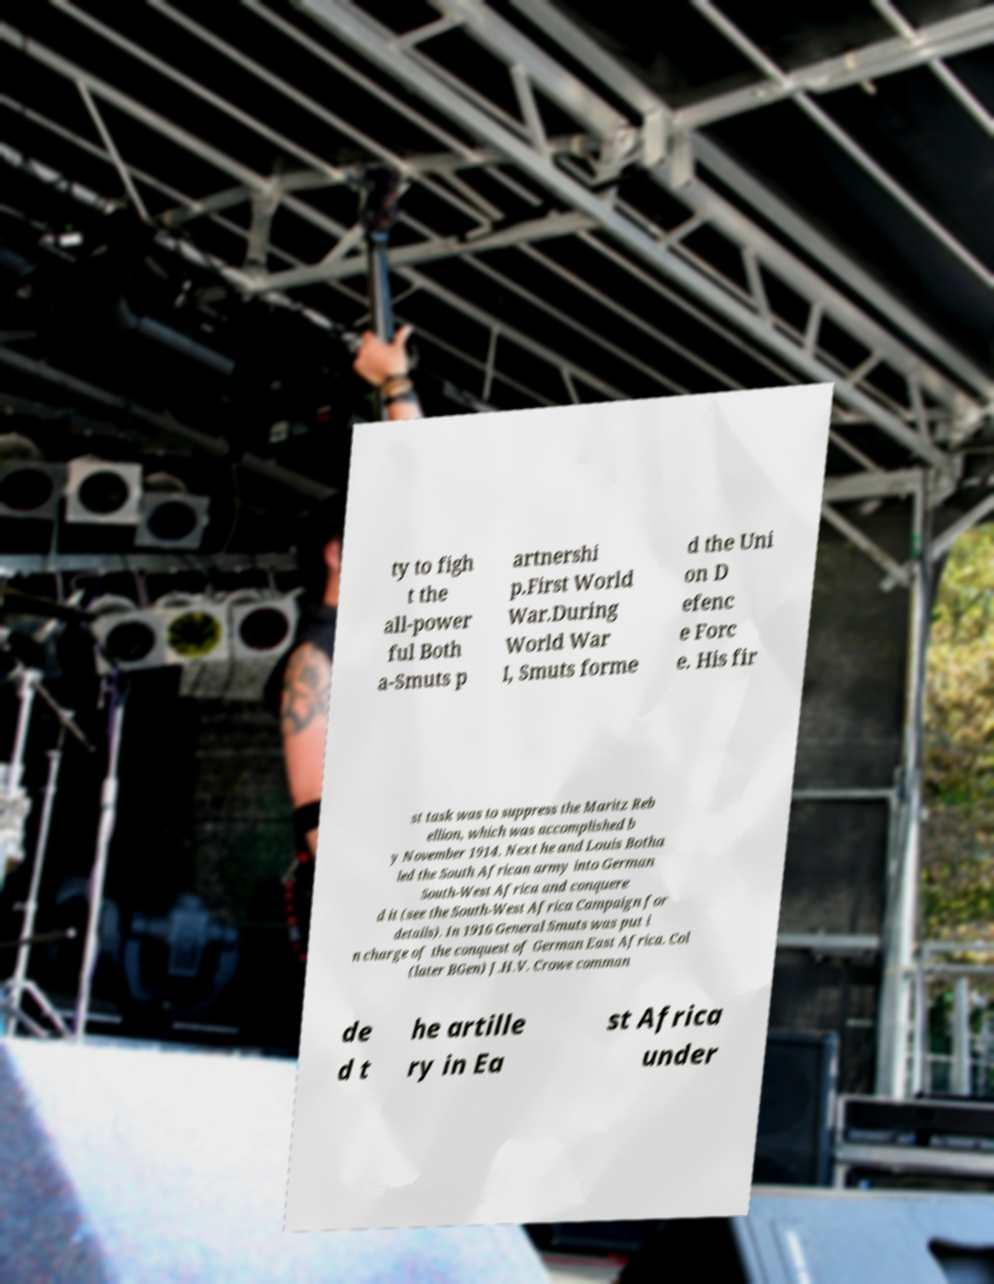I need the written content from this picture converted into text. Can you do that? ty to figh t the all-power ful Both a-Smuts p artnershi p.First World War.During World War I, Smuts forme d the Uni on D efenc e Forc e. His fir st task was to suppress the Maritz Reb ellion, which was accomplished b y November 1914. Next he and Louis Botha led the South African army into German South-West Africa and conquere d it (see the South-West Africa Campaign for details). In 1916 General Smuts was put i n charge of the conquest of German East Africa. Col (later BGen) J.H.V. Crowe comman de d t he artille ry in Ea st Africa under 